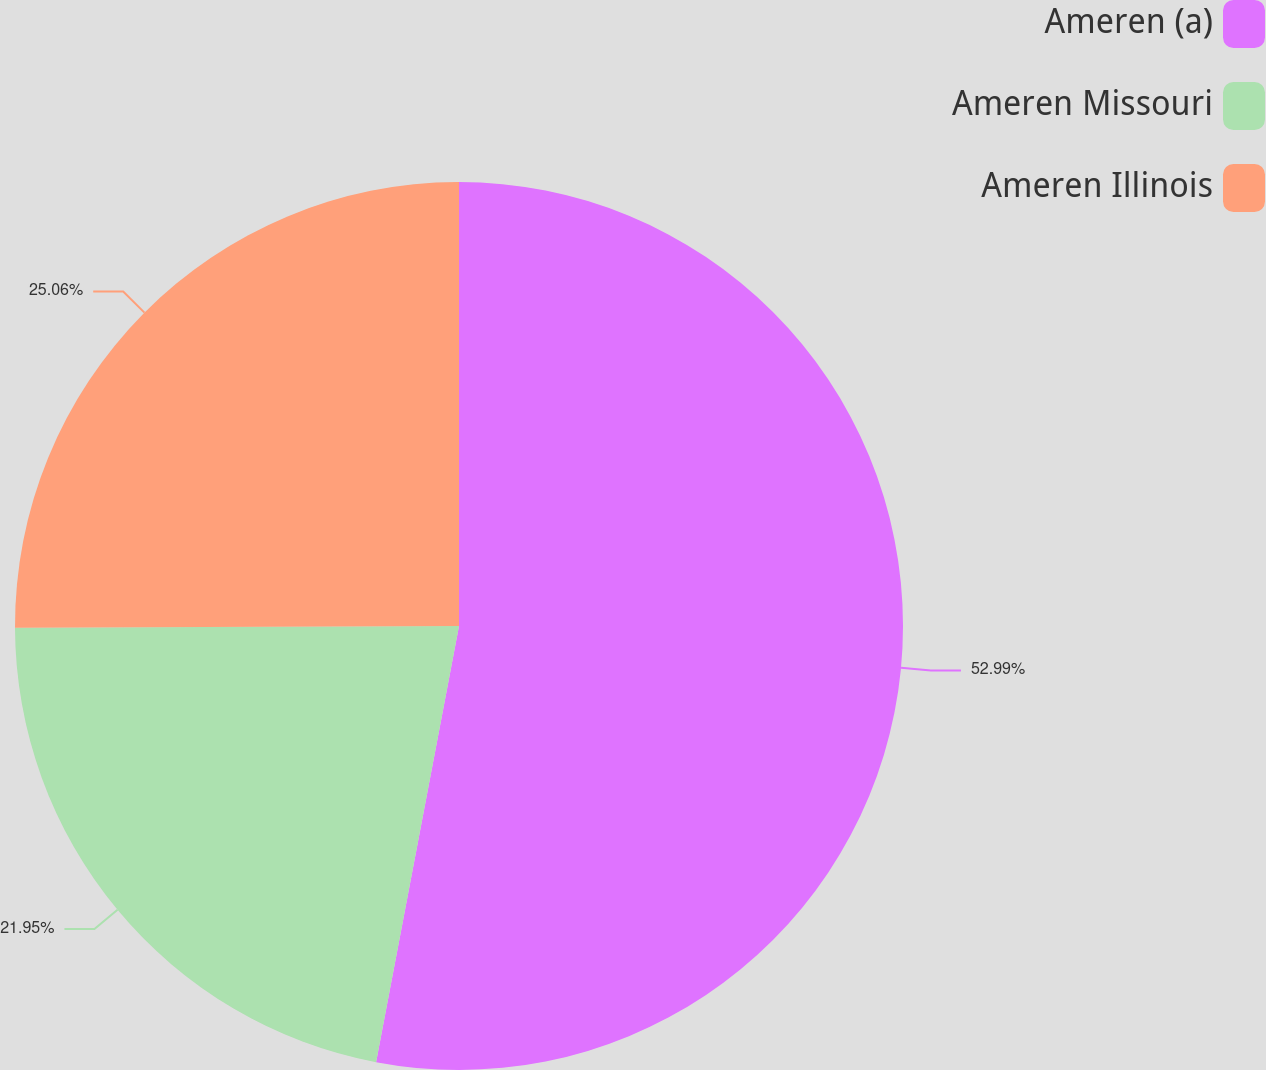<chart> <loc_0><loc_0><loc_500><loc_500><pie_chart><fcel>Ameren (a)<fcel>Ameren Missouri<fcel>Ameren Illinois<nl><fcel>52.99%<fcel>21.95%<fcel>25.06%<nl></chart> 